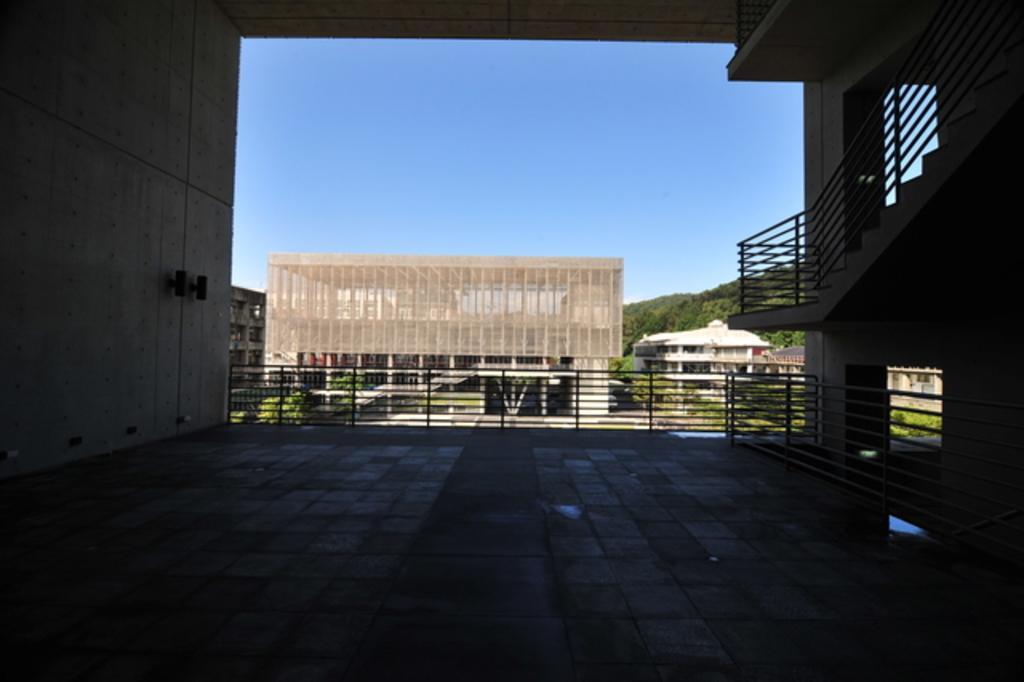Please provide a concise description of this image. In the foreground of this picture we can see the pavement, deck rail, stair case, hand rail. In the background we can see the sky, trees and the buildings and some plants. 